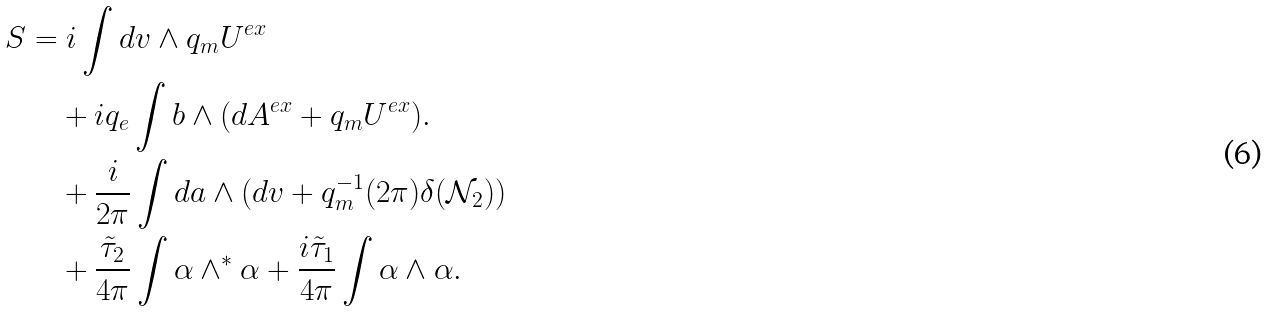<formula> <loc_0><loc_0><loc_500><loc_500>S & = i \int d v \wedge q _ { m } U ^ { e x } \\ & \quad + i q _ { e } \int b \wedge ( d A ^ { e x } + q _ { m } U ^ { e x } ) . \\ & \quad + \frac { i } { 2 \pi } \int d a \wedge ( d v + q ^ { - 1 } _ { m } ( 2 \pi ) \delta ( \mathcal { N } _ { 2 } ) ) \\ & \quad + \frac { \tilde { \tau } _ { 2 } } { 4 \pi } \int \alpha \wedge ^ { * } \alpha + \frac { i \tilde { \tau } _ { 1 } } { 4 \pi } \int \alpha \wedge \alpha .</formula> 